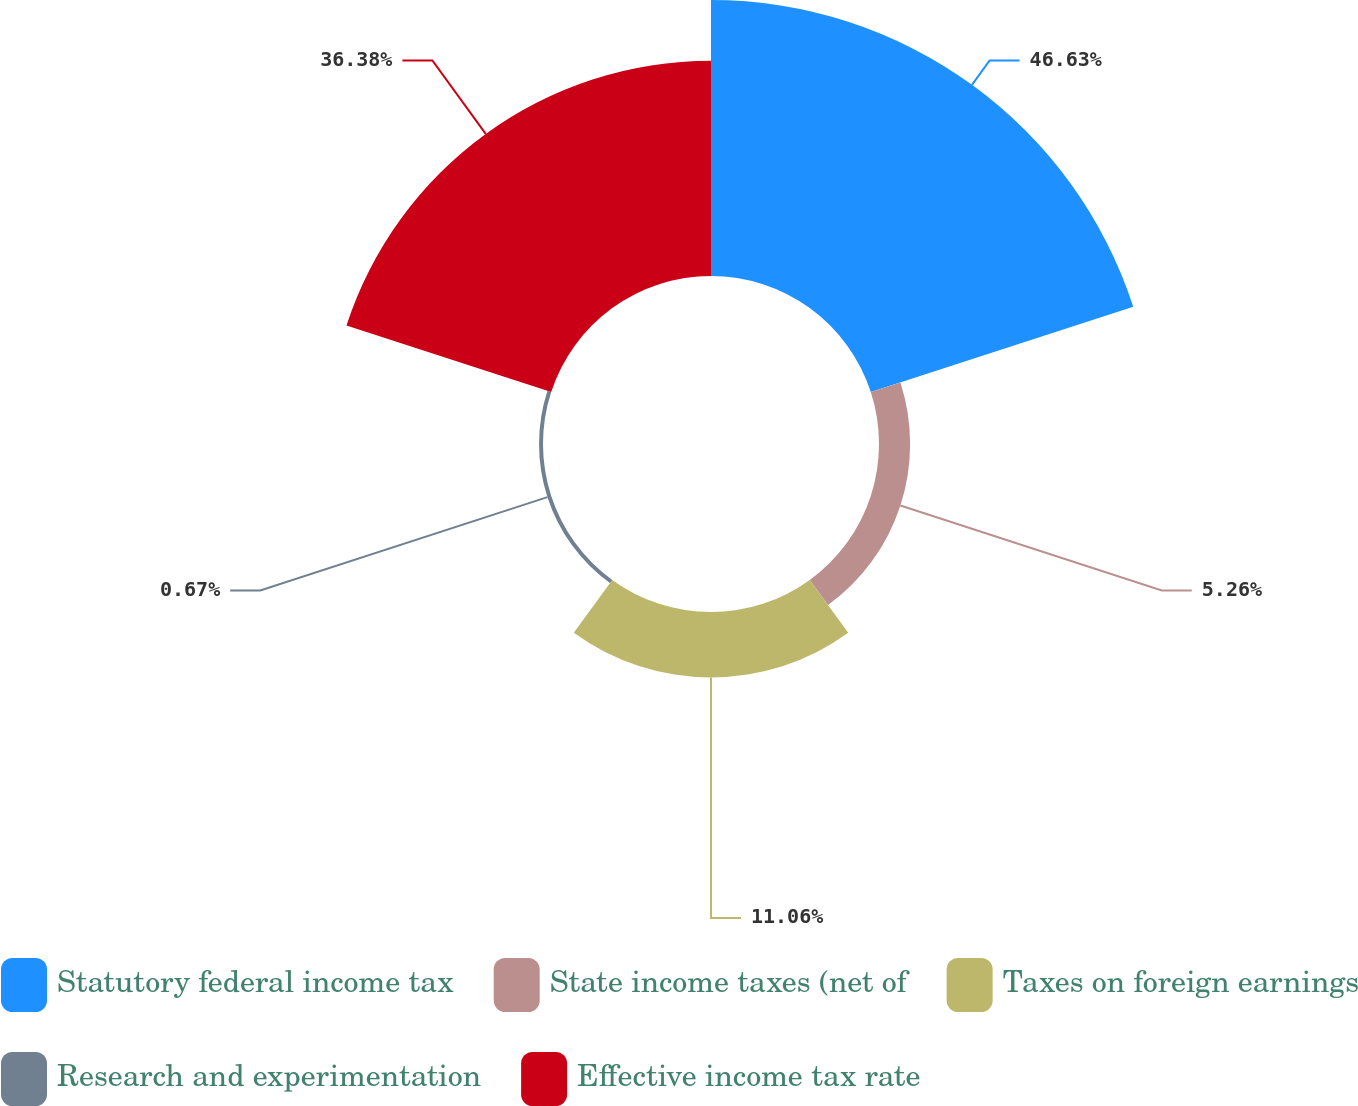Convert chart. <chart><loc_0><loc_0><loc_500><loc_500><pie_chart><fcel>Statutory federal income tax<fcel>State income taxes (net of<fcel>Taxes on foreign earnings<fcel>Research and experimentation<fcel>Effective income tax rate<nl><fcel>46.64%<fcel>5.26%<fcel>11.06%<fcel>0.67%<fcel>36.38%<nl></chart> 